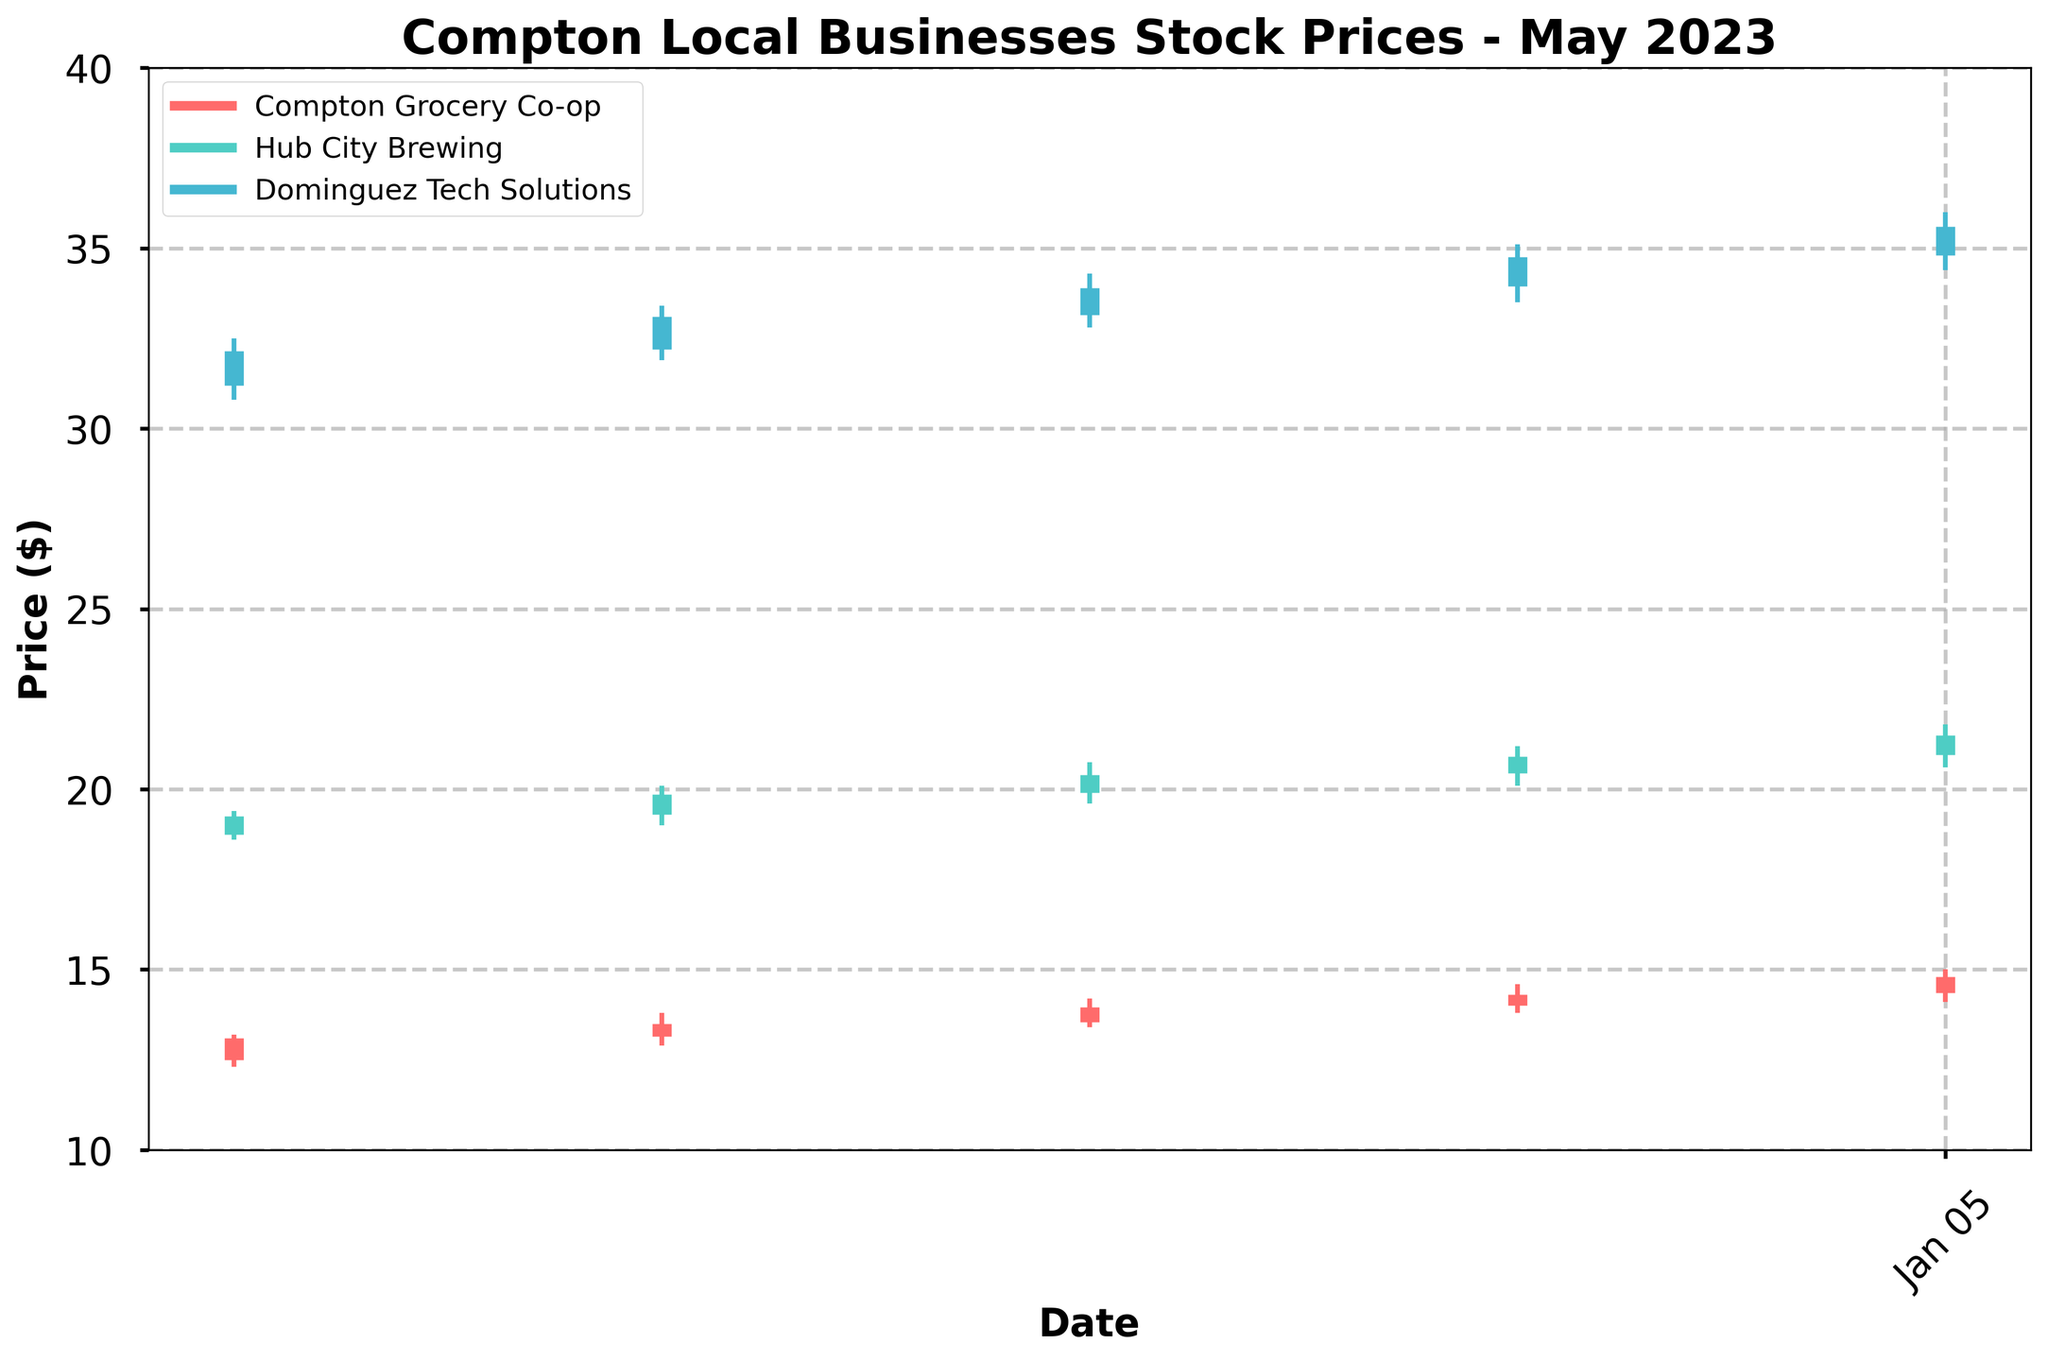what is the title of the figure? The title of the figure is located at the top of the plot. It is specifically designed to inform the viewer about the main subject of the visual representation.
Answer: Compton Local Businesses Stock Prices - May 2023 how many local businesses are tracked in the plot? Each business is represented by its own color in the plot's legend. Counting these distinct colors will provide the number of businesses tracked.
Answer: 3 what color represents Dominguez Tech Solutions in the plot? By looking at the legend on the plot, you can see which color corresponds to Dominguez Tech Solutions.
Answer: Blue what is the highest price recorded for Hub City Brewing in May? To find the highest price for Hub City Brewing, you need to look at the topmost point of the vertical lines that represent Hub City Brewing's price fluctuations.
Answer: 21.80 which company had the smallest price range on May 15? For each company, calculate the price range by subtracting the lowest price from the highest price on May 15. The company with the smallest difference has the smallest price range. 
- Compton Grocery Co-op: 14.20 - 13.40 = 0.80
- Hub City Brewing: 20.75 - 19.60 = 1.15
- Dominguez Tech Solutions: 34.30 - 32.80 = 1.50
Answer: Compton Grocery Co-op which company showed the greatest price increase from May 1 to May 29? To determine this, calculate the difference between the closing price on May 29 and the closing price on May 1 for each company.
- Compton Grocery Co-op: 14.80 - 13.10 = 1.70
- Hub City Brewing: 21.50 - 19.25 = 2.25
- Dominguez Tech Solutions: 35.60 - 32.15 = 3.45
Answer: Dominguez Tech Solutions what is the closing price for Compton Grocery Co-op on May 22? Locate the date May 22 in the plot's x-axis and then look at the corresponding closing price for Compton Grocery Co-op, which is marked with a thick vertical line end.
Answer: 14.30 what was the average closing price of Hub City Brewing over the four weeks? Sum all the closing prices for each week for Hub City Brewing and then divide by the number of weeks.
(19.25 + 19.85 + 20.40 + 20.90 + 21.50) / 5 = 101.90 / 5
Answer: 20.38 which company had a closing price higher than 33 on May 8? Examine the closing prices for each company on May 8, and identify any that are higher than 33.
- Dominguez Tech Solutions has a closing price of 33.10
Answer: Dominguez Tech Solutions 